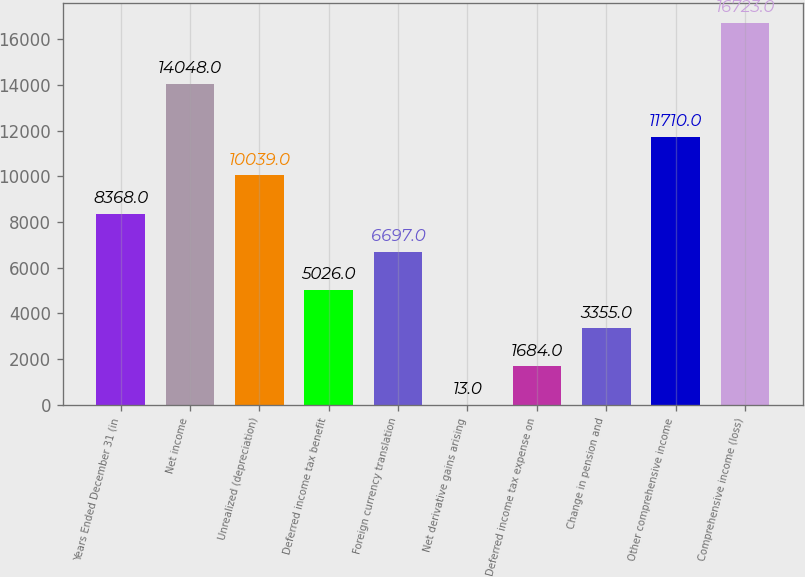Convert chart to OTSL. <chart><loc_0><loc_0><loc_500><loc_500><bar_chart><fcel>Years Ended December 31 (in<fcel>Net income<fcel>Unrealized (depreciation)<fcel>Deferred income tax benefit<fcel>Foreign currency translation<fcel>Net derivative gains arising<fcel>Deferred income tax expense on<fcel>Change in pension and<fcel>Other comprehensive income<fcel>Comprehensive income (loss)<nl><fcel>8368<fcel>14048<fcel>10039<fcel>5026<fcel>6697<fcel>13<fcel>1684<fcel>3355<fcel>11710<fcel>16723<nl></chart> 